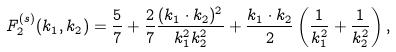Convert formula to latex. <formula><loc_0><loc_0><loc_500><loc_500>F ^ { ( s ) } _ { 2 } ( { k } _ { 1 } , { k } _ { 2 } ) = \frac { 5 } { 7 } + \frac { 2 } { 7 } \frac { ( { k } _ { 1 } \cdot { k } _ { 2 } ) ^ { 2 } } { k ^ { 2 } _ { 1 } k ^ { 2 } _ { 2 } } + \frac { { k } _ { 1 } \cdot { k } _ { 2 } } { 2 } \left ( \frac { 1 } { k ^ { 2 } _ { 1 } } + \frac { 1 } { k ^ { 2 } _ { 2 } } \right ) ,</formula> 